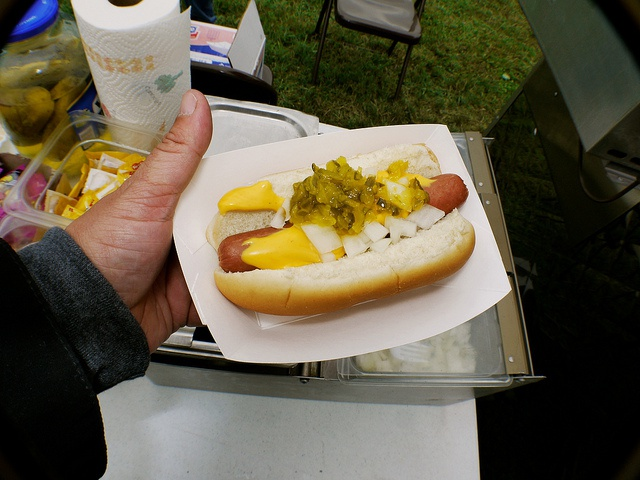Describe the objects in this image and their specific colors. I can see people in black, brown, maroon, and tan tones, hot dog in black, tan, olive, and gold tones, and chair in black and gray tones in this image. 